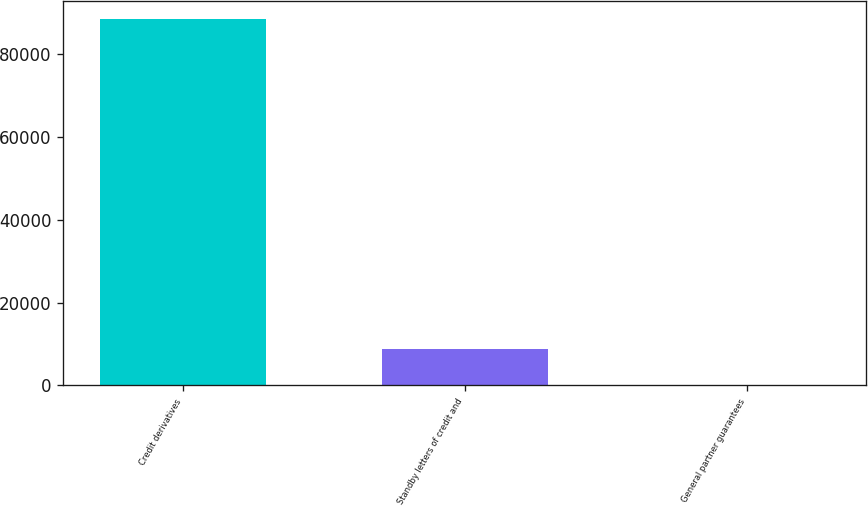<chart> <loc_0><loc_0><loc_500><loc_500><bar_chart><fcel>Credit derivatives<fcel>Standby letters of credit and<fcel>General partner guarantees<nl><fcel>88226<fcel>8851.4<fcel>32<nl></chart> 